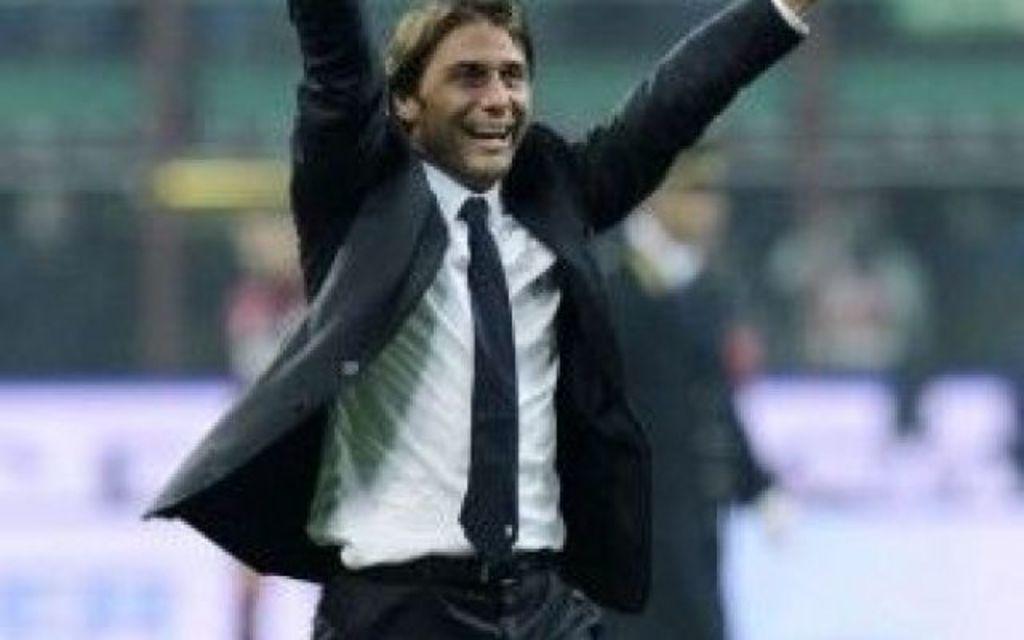How would you summarize this image in a sentence or two? There is a man standing and smiling and wore suit. In the background it is blur. 